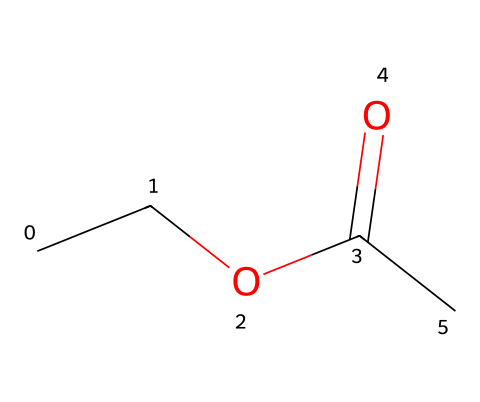What is the name of this chemical? The chemical structure corresponds to the SMILES representation provided, which is identified as ethyl acetate, commonly used as a solvent.
Answer: ethyl acetate How many carbon atoms are in ethyl acetate? By analyzing the structure and the SMILES notation (CCOC(=O)C), there are a total of four carbon atoms present.
Answer: 4 What type of functional group is present in ethyl acetate? The molecule contains an ester functional group, indicated by the -COO- part in the structure, which characterizes it as an ester.
Answer: ester What is the total number of oxygen atoms in ethyl acetate? The structure shows two oxygens: one is part of the carbonyl (C=O) and the other is part of the ether (C-O) group, resulting in a total of two oxygen atoms.
Answer: 2 How many hydrogen atoms are in the molecule? From the structure, counting the hydrogen atoms attached to the carbons, there are a total of eight hydrogen atoms in ethyl acetate.
Answer: 8 What type of reaction would produce ethyl acetate? Ethyl acetate is typically formed through the esterification reaction, which involves the reaction of an alcohol and a carboxylic acid.
Answer: esterification Which part of ethyl acetate determines its solvent properties? The ester functional group (particularly the -COO- part) gives ethyl acetate its solvent properties, as it can dissolve both polar and non-polar compounds.
Answer: -COO- 